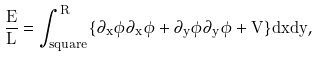<formula> <loc_0><loc_0><loc_500><loc_500>\frac { E } { L } = \int _ { s q u a r e } ^ { R } \{ \partial _ { x } \bar { \phi } \partial _ { x } \phi + \partial _ { y } \bar { \phi } \partial _ { y } \phi + V \} d x d y ,</formula> 